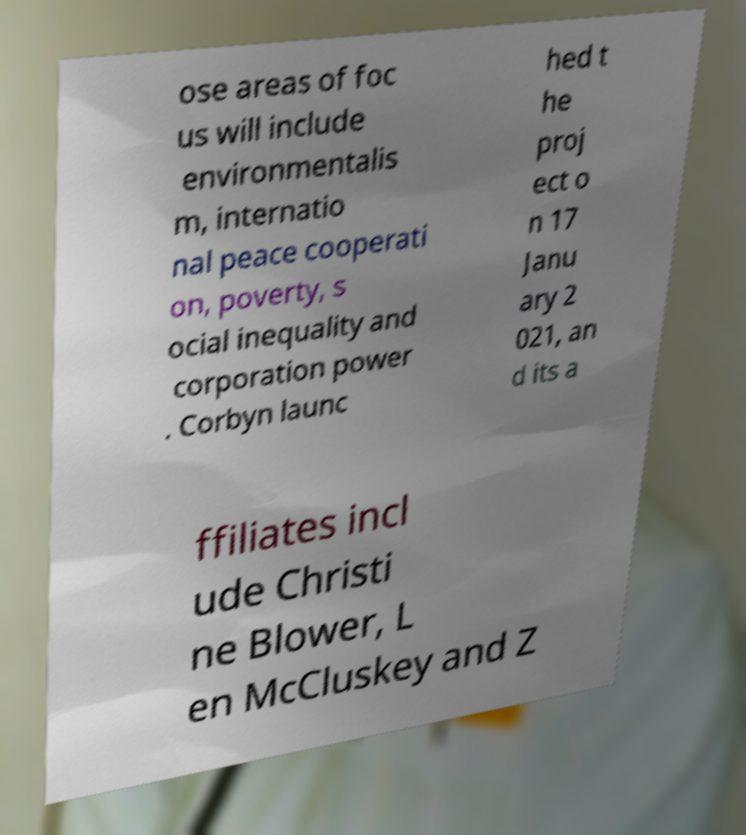For documentation purposes, I need the text within this image transcribed. Could you provide that? ose areas of foc us will include environmentalis m, internatio nal peace cooperati on, poverty, s ocial inequality and corporation power . Corbyn launc hed t he proj ect o n 17 Janu ary 2 021, an d its a ffiliates incl ude Christi ne Blower, L en McCluskey and Z 